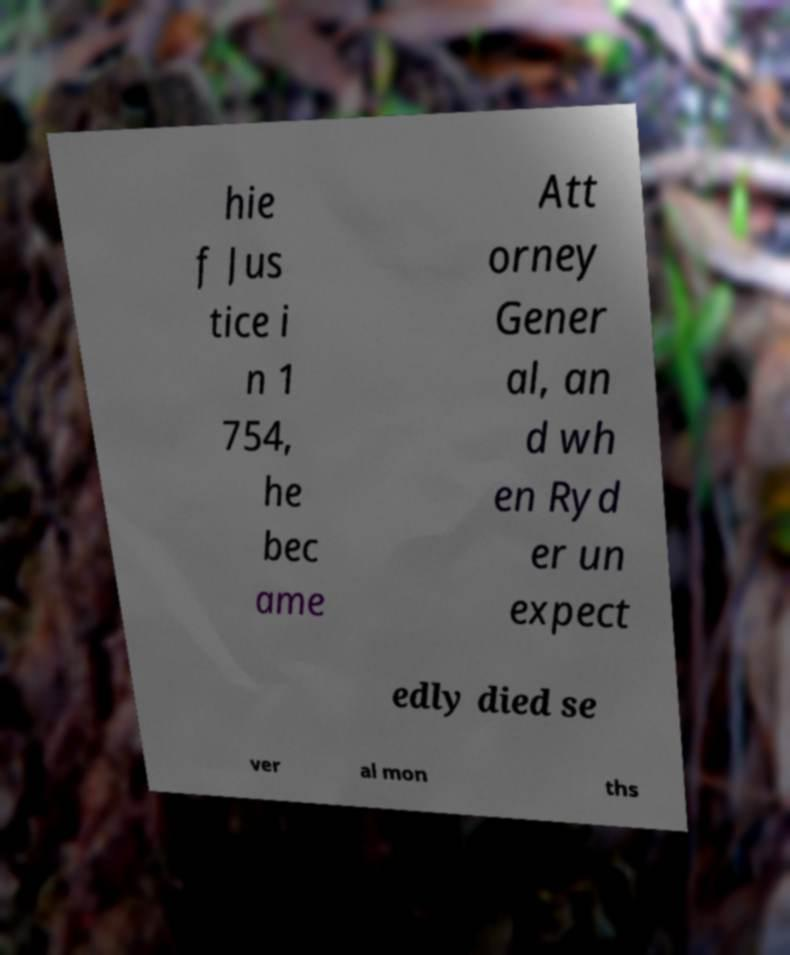Please identify and transcribe the text found in this image. hie f Jus tice i n 1 754, he bec ame Att orney Gener al, an d wh en Ryd er un expect edly died se ver al mon ths 